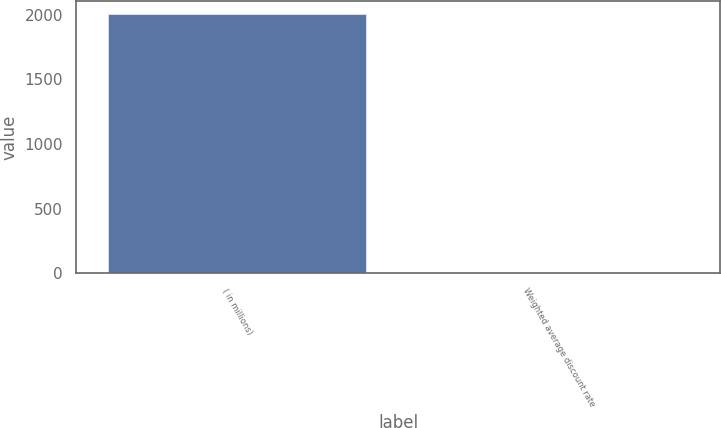Convert chart to OTSL. <chart><loc_0><loc_0><loc_500><loc_500><bar_chart><fcel>( in millions)<fcel>Weighted average discount rate<nl><fcel>2006<fcel>6<nl></chart> 